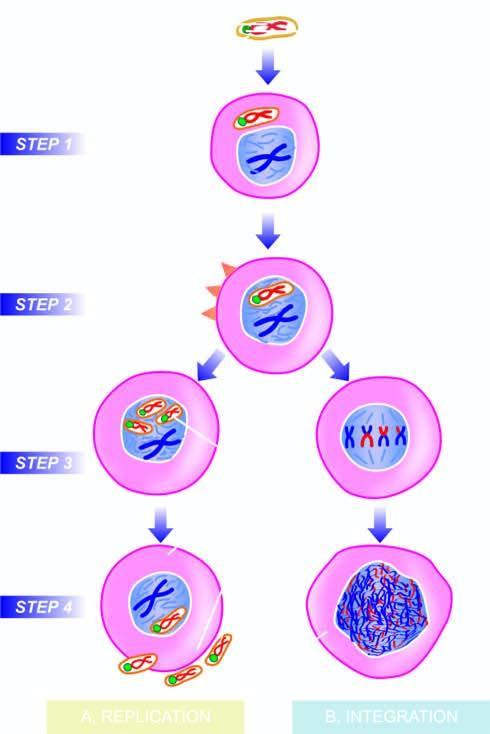what is expressed immediately after infection?
Answer the question using a single word or phrase. T-antigen 